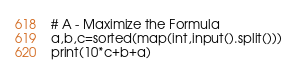Convert code to text. <code><loc_0><loc_0><loc_500><loc_500><_Python_># A - Maximize the Formula
a,b,c=sorted(map(int,input().split()))
print(10*c+b+a)
</code> 